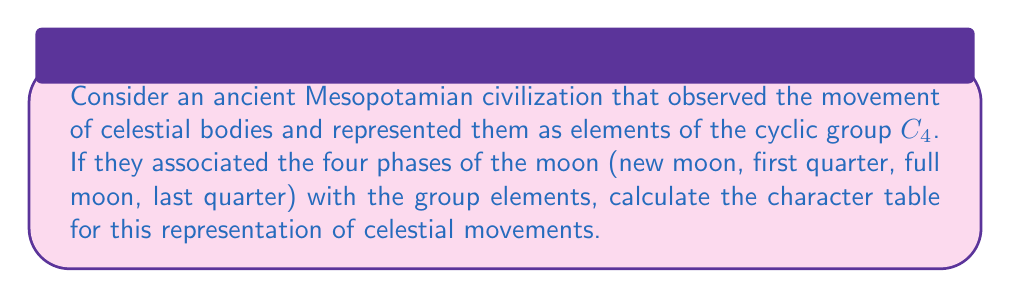Help me with this question. To calculate the character table for this representation, we'll follow these steps:

1) First, identify the group: $C_4$ (cyclic group of order 4)

2) List the conjugacy classes of $C_4$:
   $[e]$, $[r]$, $[r^2]$, $[r^3]$, where $r$ is a 90° rotation

3) Determine the irreducible representations:
   $C_4$ has 4 one-dimensional irreducible representations, which we'll call $\chi_0$, $\chi_1$, $\chi_2$, and $\chi_3$

4) Calculate the characters for each representation:

   For $\chi_0$ (trivial representation):
   $\chi_0(e) = \chi_0(r) = \chi_0(r^2) = \chi_0(r^3) = 1$

   For $\chi_1$:
   $\chi_1(e) = 1$, $\chi_1(r) = i$, $\chi_1(r^2) = -1$, $\chi_1(r^3) = -i$

   For $\chi_2$:
   $\chi_2(e) = 1$, $\chi_2(r) = -1$, $\chi_2(r^2) = 1$, $\chi_2(r^3) = -1$

   For $\chi_3$:
   $\chi_3(e) = 1$, $\chi_3(r) = -i$, $\chi_3(r^2) = -1$, $\chi_3(r^3) = i$

5) Construct the character table:

   $$
   \begin{array}{c|cccc}
    C_4 & [e] & [r] & [r^2] & [r^3] \\
    \hline
    \chi_0 & 1 & 1 & 1 & 1 \\
    \chi_1 & 1 & i & -1 & -i \\
    \chi_2 & 1 & -1 & 1 & -1 \\
    \chi_3 & 1 & -i & -1 & i
   \end{array}
   $$

This character table represents how the ancient civilization's understanding of celestial movements (specifically the moon phases) corresponds to the mathematical structure of the cyclic group $C_4$.
Answer: $$
\begin{array}{c|cccc}
C_4 & [e] & [r] & [r^2] & [r^3] \\
\hline
\chi_0 & 1 & 1 & 1 & 1 \\
\chi_1 & 1 & i & -1 & -i \\
\chi_2 & 1 & -1 & 1 & -1 \\
\chi_3 & 1 & -i & -1 & i
\end{array}
$$ 